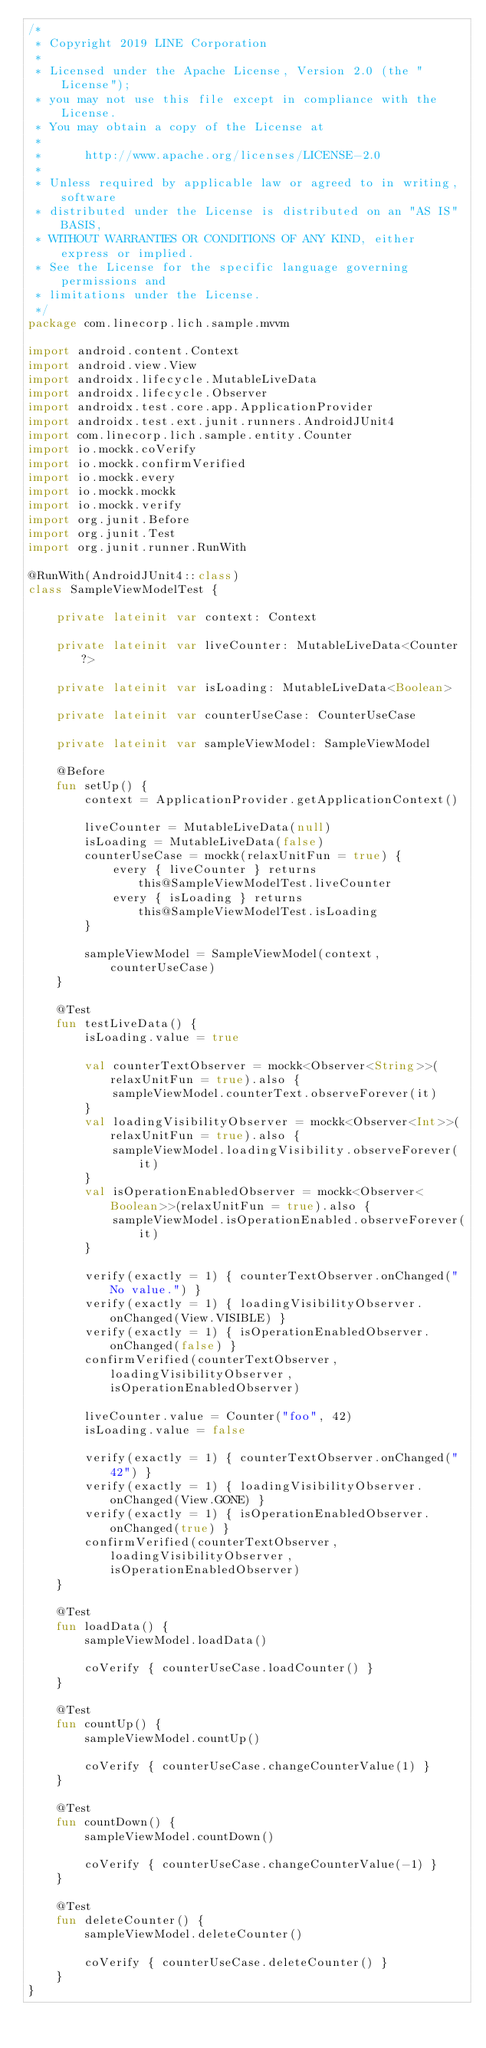Convert code to text. <code><loc_0><loc_0><loc_500><loc_500><_Kotlin_>/*
 * Copyright 2019 LINE Corporation
 *
 * Licensed under the Apache License, Version 2.0 (the "License");
 * you may not use this file except in compliance with the License.
 * You may obtain a copy of the License at
 *
 *      http://www.apache.org/licenses/LICENSE-2.0
 *
 * Unless required by applicable law or agreed to in writing, software
 * distributed under the License is distributed on an "AS IS" BASIS,
 * WITHOUT WARRANTIES OR CONDITIONS OF ANY KIND, either express or implied.
 * See the License for the specific language governing permissions and
 * limitations under the License.
 */
package com.linecorp.lich.sample.mvvm

import android.content.Context
import android.view.View
import androidx.lifecycle.MutableLiveData
import androidx.lifecycle.Observer
import androidx.test.core.app.ApplicationProvider
import androidx.test.ext.junit.runners.AndroidJUnit4
import com.linecorp.lich.sample.entity.Counter
import io.mockk.coVerify
import io.mockk.confirmVerified
import io.mockk.every
import io.mockk.mockk
import io.mockk.verify
import org.junit.Before
import org.junit.Test
import org.junit.runner.RunWith

@RunWith(AndroidJUnit4::class)
class SampleViewModelTest {

    private lateinit var context: Context

    private lateinit var liveCounter: MutableLiveData<Counter?>

    private lateinit var isLoading: MutableLiveData<Boolean>

    private lateinit var counterUseCase: CounterUseCase

    private lateinit var sampleViewModel: SampleViewModel

    @Before
    fun setUp() {
        context = ApplicationProvider.getApplicationContext()

        liveCounter = MutableLiveData(null)
        isLoading = MutableLiveData(false)
        counterUseCase = mockk(relaxUnitFun = true) {
            every { liveCounter } returns this@SampleViewModelTest.liveCounter
            every { isLoading } returns this@SampleViewModelTest.isLoading
        }

        sampleViewModel = SampleViewModel(context, counterUseCase)
    }

    @Test
    fun testLiveData() {
        isLoading.value = true

        val counterTextObserver = mockk<Observer<String>>(relaxUnitFun = true).also {
            sampleViewModel.counterText.observeForever(it)
        }
        val loadingVisibilityObserver = mockk<Observer<Int>>(relaxUnitFun = true).also {
            sampleViewModel.loadingVisibility.observeForever(it)
        }
        val isOperationEnabledObserver = mockk<Observer<Boolean>>(relaxUnitFun = true).also {
            sampleViewModel.isOperationEnabled.observeForever(it)
        }

        verify(exactly = 1) { counterTextObserver.onChanged("No value.") }
        verify(exactly = 1) { loadingVisibilityObserver.onChanged(View.VISIBLE) }
        verify(exactly = 1) { isOperationEnabledObserver.onChanged(false) }
        confirmVerified(counterTextObserver, loadingVisibilityObserver, isOperationEnabledObserver)

        liveCounter.value = Counter("foo", 42)
        isLoading.value = false

        verify(exactly = 1) { counterTextObserver.onChanged("42") }
        verify(exactly = 1) { loadingVisibilityObserver.onChanged(View.GONE) }
        verify(exactly = 1) { isOperationEnabledObserver.onChanged(true) }
        confirmVerified(counterTextObserver, loadingVisibilityObserver, isOperationEnabledObserver)
    }

    @Test
    fun loadData() {
        sampleViewModel.loadData()

        coVerify { counterUseCase.loadCounter() }
    }

    @Test
    fun countUp() {
        sampleViewModel.countUp()

        coVerify { counterUseCase.changeCounterValue(1) }
    }

    @Test
    fun countDown() {
        sampleViewModel.countDown()

        coVerify { counterUseCase.changeCounterValue(-1) }
    }

    @Test
    fun deleteCounter() {
        sampleViewModel.deleteCounter()

        coVerify { counterUseCase.deleteCounter() }
    }
}
</code> 